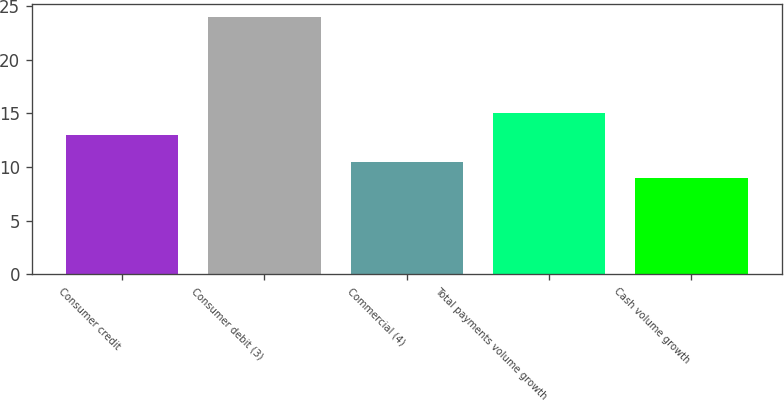Convert chart to OTSL. <chart><loc_0><loc_0><loc_500><loc_500><bar_chart><fcel>Consumer credit<fcel>Consumer debit (3)<fcel>Commercial (4)<fcel>Total payments volume growth<fcel>Cash volume growth<nl><fcel>13<fcel>24<fcel>10.5<fcel>15<fcel>9<nl></chart> 